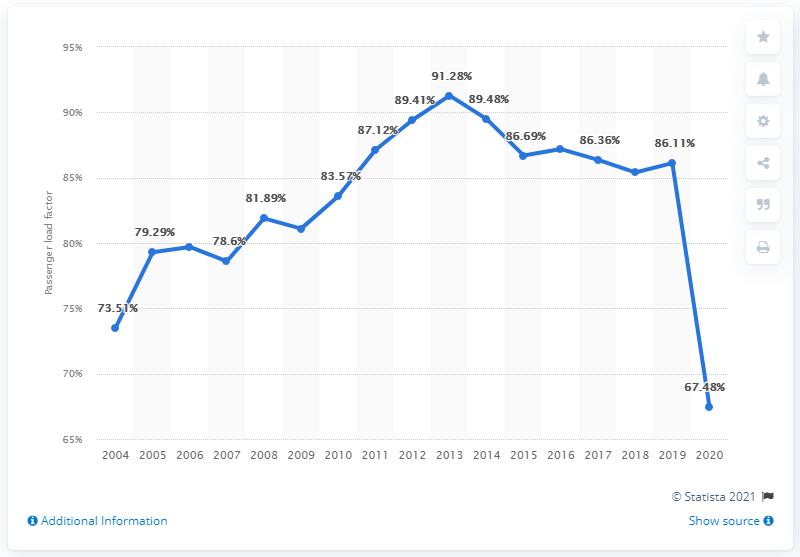Outline some significant characteristics in this image. Ninety-five percent of passengers are over the age of 85. The year 2020 witnessed a significant decline in passenger numbers. 